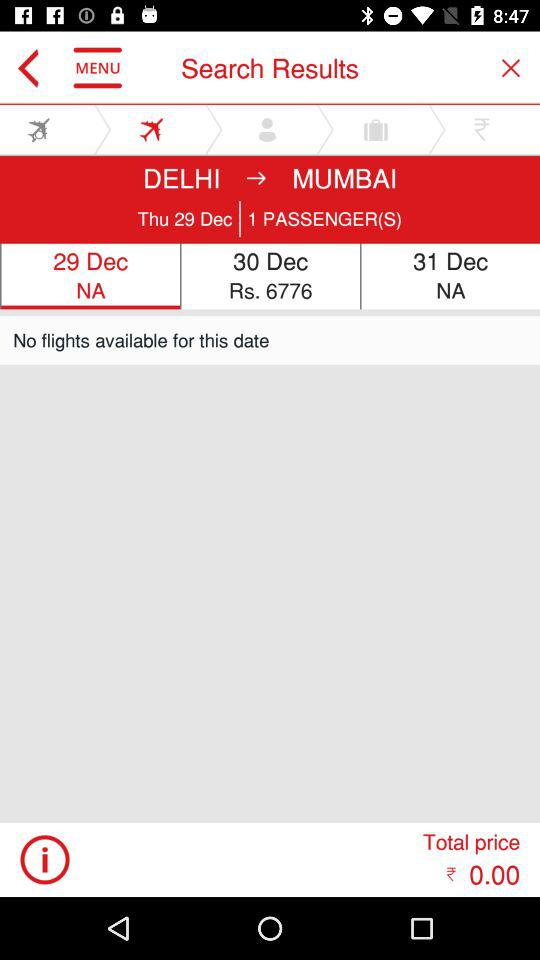How many people are flying?
Answer the question using a single word or phrase. 1 